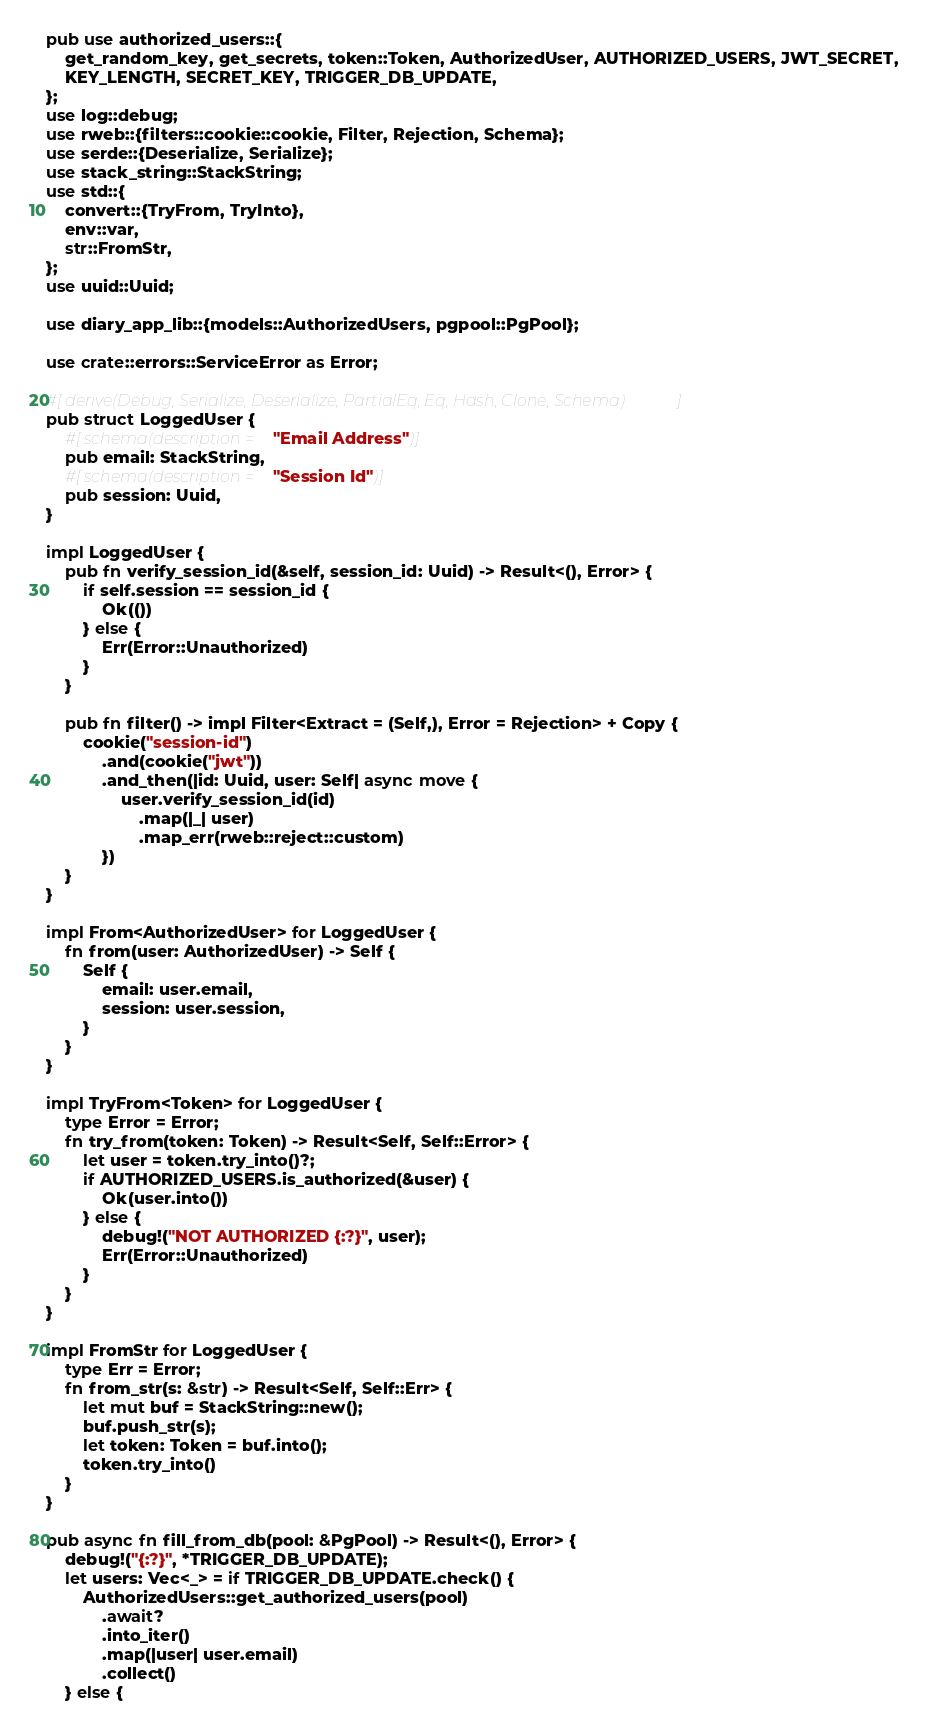Convert code to text. <code><loc_0><loc_0><loc_500><loc_500><_Rust_>pub use authorized_users::{
    get_random_key, get_secrets, token::Token, AuthorizedUser, AUTHORIZED_USERS, JWT_SECRET,
    KEY_LENGTH, SECRET_KEY, TRIGGER_DB_UPDATE,
};
use log::debug;
use rweb::{filters::cookie::cookie, Filter, Rejection, Schema};
use serde::{Deserialize, Serialize};
use stack_string::StackString;
use std::{
    convert::{TryFrom, TryInto},
    env::var,
    str::FromStr,
};
use uuid::Uuid;

use diary_app_lib::{models::AuthorizedUsers, pgpool::PgPool};

use crate::errors::ServiceError as Error;

#[derive(Debug, Serialize, Deserialize, PartialEq, Eq, Hash, Clone, Schema)]
pub struct LoggedUser {
    #[schema(description = "Email Address")]
    pub email: StackString,
    #[schema(description = "Session Id")]
    pub session: Uuid,
}

impl LoggedUser {
    pub fn verify_session_id(&self, session_id: Uuid) -> Result<(), Error> {
        if self.session == session_id {
            Ok(())
        } else {
            Err(Error::Unauthorized)
        }
    }

    pub fn filter() -> impl Filter<Extract = (Self,), Error = Rejection> + Copy {
        cookie("session-id")
            .and(cookie("jwt"))
            .and_then(|id: Uuid, user: Self| async move {
                user.verify_session_id(id)
                    .map(|_| user)
                    .map_err(rweb::reject::custom)
            })
    }
}

impl From<AuthorizedUser> for LoggedUser {
    fn from(user: AuthorizedUser) -> Self {
        Self {
            email: user.email,
            session: user.session,
        }
    }
}

impl TryFrom<Token> for LoggedUser {
    type Error = Error;
    fn try_from(token: Token) -> Result<Self, Self::Error> {
        let user = token.try_into()?;
        if AUTHORIZED_USERS.is_authorized(&user) {
            Ok(user.into())
        } else {
            debug!("NOT AUTHORIZED {:?}", user);
            Err(Error::Unauthorized)
        }
    }
}

impl FromStr for LoggedUser {
    type Err = Error;
    fn from_str(s: &str) -> Result<Self, Self::Err> {
        let mut buf = StackString::new();
        buf.push_str(s);
        let token: Token = buf.into();
        token.try_into()
    }
}

pub async fn fill_from_db(pool: &PgPool) -> Result<(), Error> {
    debug!("{:?}", *TRIGGER_DB_UPDATE);
    let users: Vec<_> = if TRIGGER_DB_UPDATE.check() {
        AuthorizedUsers::get_authorized_users(pool)
            .await?
            .into_iter()
            .map(|user| user.email)
            .collect()
    } else {</code> 